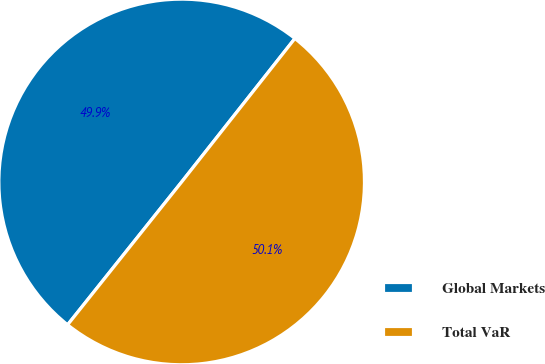<chart> <loc_0><loc_0><loc_500><loc_500><pie_chart><fcel>Global Markets<fcel>Total VaR<nl><fcel>49.91%<fcel>50.09%<nl></chart> 